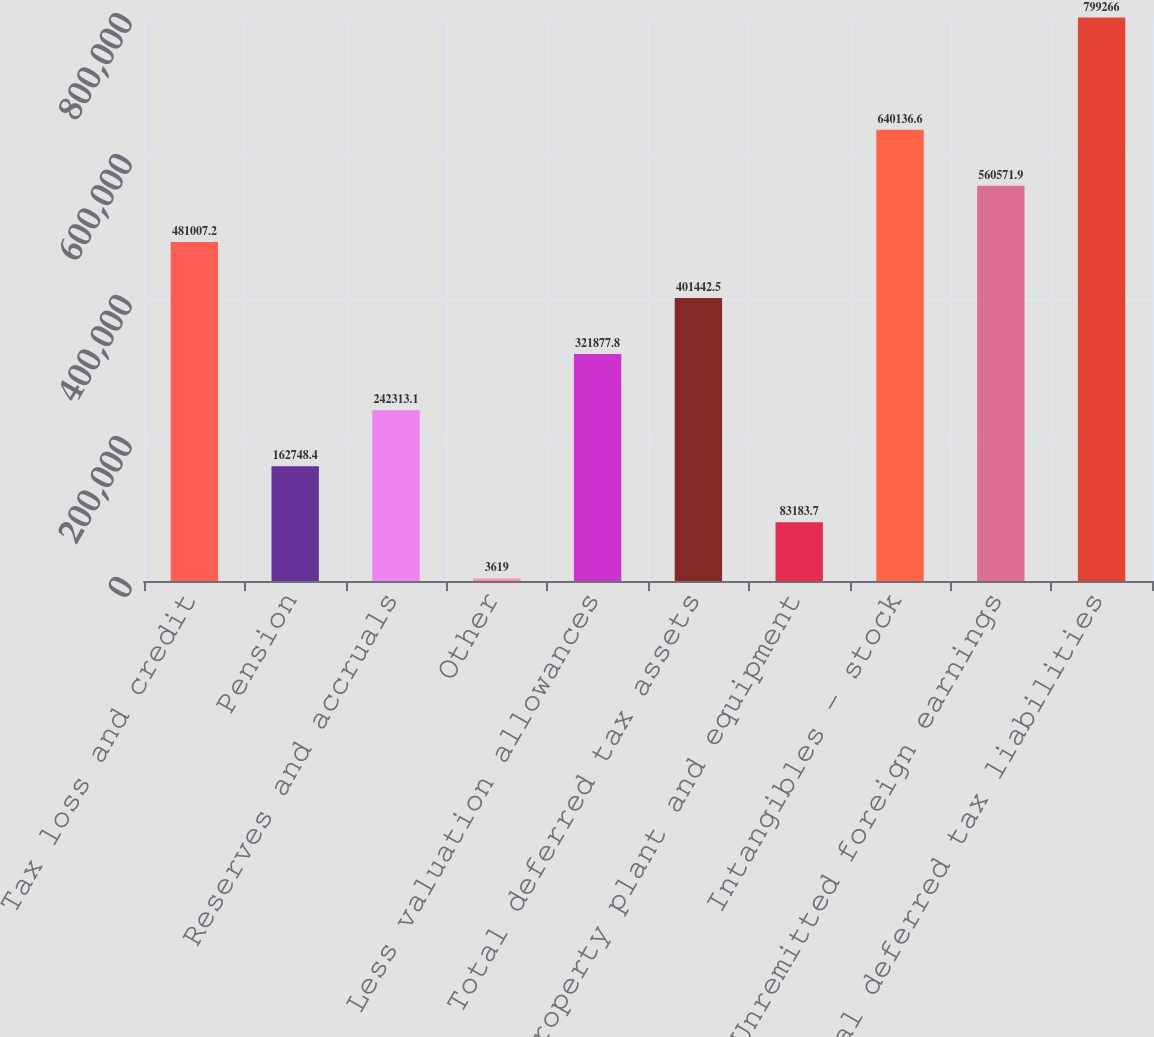<chart> <loc_0><loc_0><loc_500><loc_500><bar_chart><fcel>Tax loss and credit<fcel>Pension<fcel>Reserves and accruals<fcel>Other<fcel>Less valuation allowances<fcel>Total deferred tax assets<fcel>Property plant and equipment<fcel>Intangibles - stock<fcel>Unremitted foreign earnings<fcel>Total deferred tax liabilities<nl><fcel>481007<fcel>162748<fcel>242313<fcel>3619<fcel>321878<fcel>401442<fcel>83183.7<fcel>640137<fcel>560572<fcel>799266<nl></chart> 